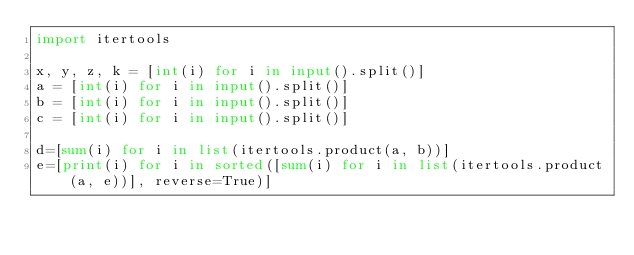Convert code to text. <code><loc_0><loc_0><loc_500><loc_500><_Python_>import itertools

x, y, z, k = [int(i) for i in input().split()]
a = [int(i) for i in input().split()]
b = [int(i) for i in input().split()]
c = [int(i) for i in input().split()]

d=[sum(i) for i in list(itertools.product(a, b))]
e=[print(i) for i in sorted([sum(i) for i in list(itertools.product(a, e))], reverse=True)]
</code> 